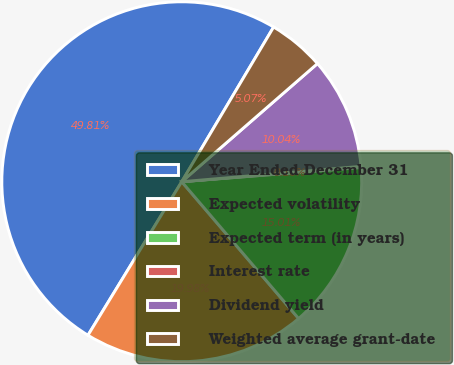Convert chart to OTSL. <chart><loc_0><loc_0><loc_500><loc_500><pie_chart><fcel>Year Ended December 31<fcel>Expected volatility<fcel>Expected term (in years)<fcel>Interest rate<fcel>Dividend yield<fcel>Weighted average grant-date<nl><fcel>49.81%<fcel>19.98%<fcel>15.01%<fcel>0.1%<fcel>10.04%<fcel>5.07%<nl></chart> 